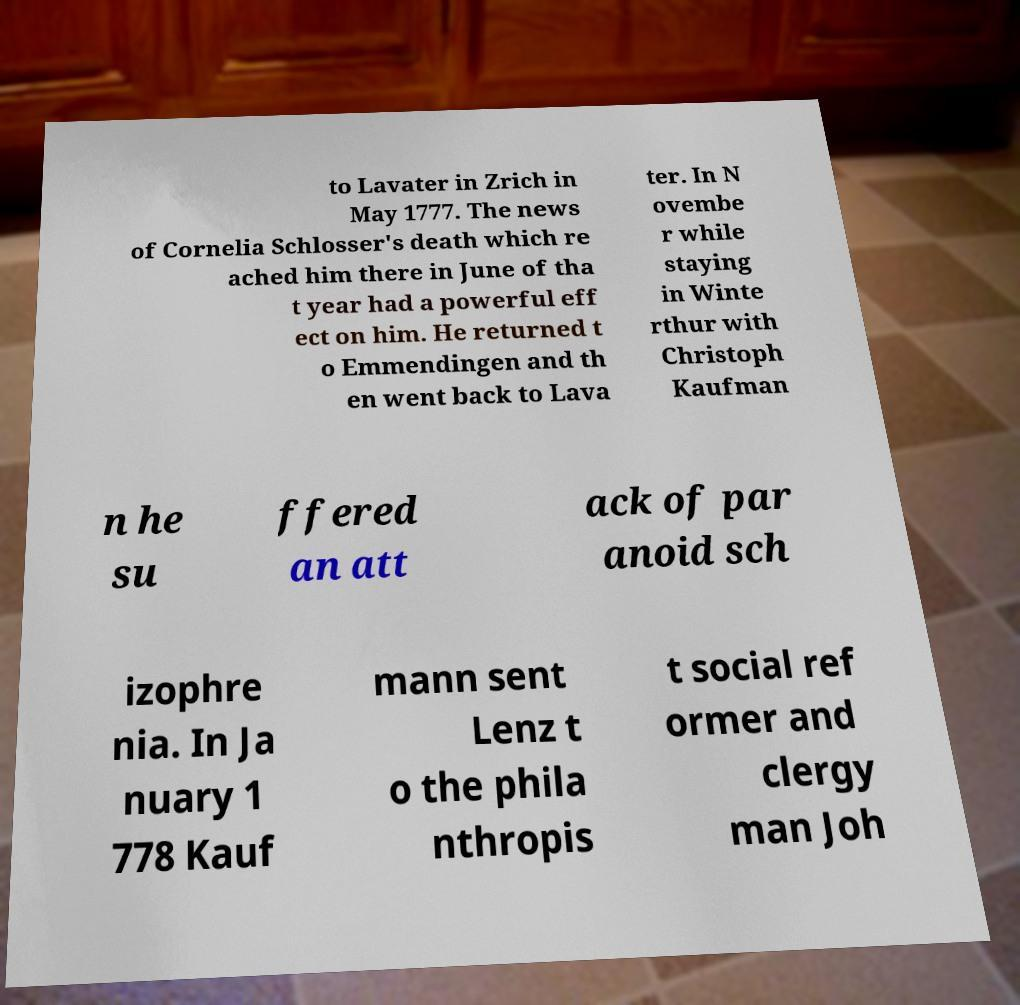Can you accurately transcribe the text from the provided image for me? to Lavater in Zrich in May 1777. The news of Cornelia Schlosser's death which re ached him there in June of tha t year had a powerful eff ect on him. He returned t o Emmendingen and th en went back to Lava ter. In N ovembe r while staying in Winte rthur with Christoph Kaufman n he su ffered an att ack of par anoid sch izophre nia. In Ja nuary 1 778 Kauf mann sent Lenz t o the phila nthropis t social ref ormer and clergy man Joh 